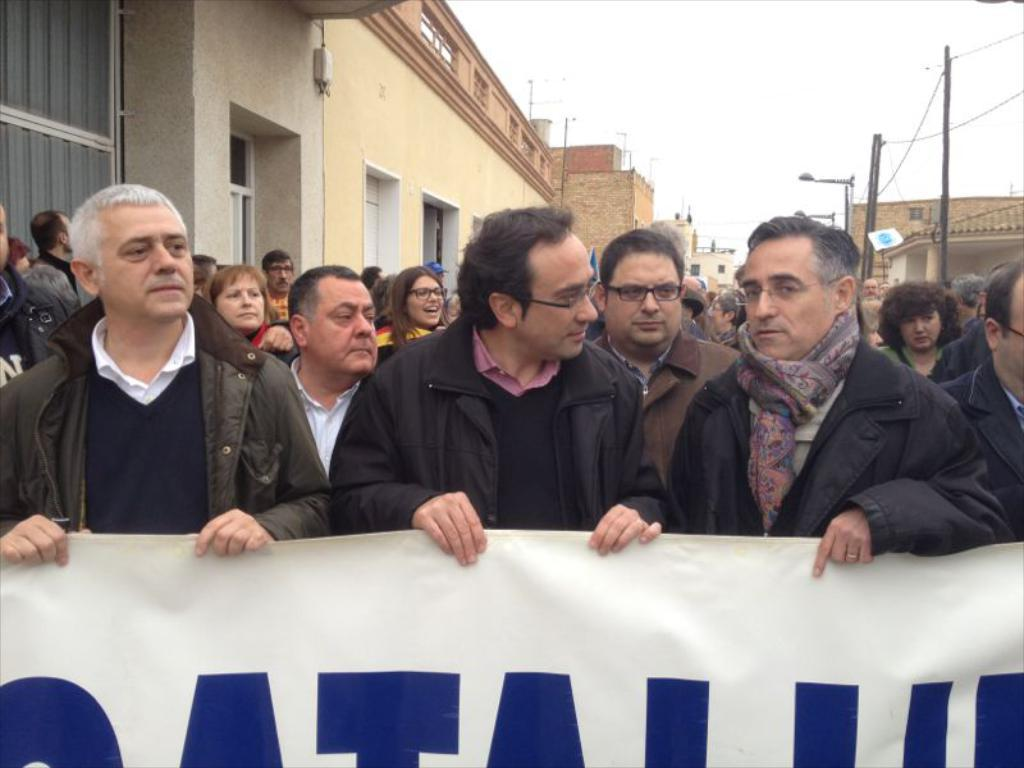What are the people in the image doing? The people in the image are standing and holding banners or boards. What can be seen in the image besides the people? There are street lights, buildings, windows, and the sky visible in the image. Can you describe the buildings in the image? The buildings have windows visible in the image. How much money is being exchanged between the people in the image? There is no indication of money being exchanged in the image; the people are holding banners or boards. 